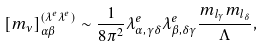<formula> <loc_0><loc_0><loc_500><loc_500>[ m _ { \nu } ] ^ { ( \lambda ^ { e } \lambda ^ { e } ) } _ { \alpha \beta } \sim \frac { 1 } { 8 \pi ^ { 2 } } \lambda ^ { e } _ { \alpha , \gamma \delta } \lambda ^ { e } _ { \beta , \delta \gamma } \frac { m _ { l _ { \gamma } } m _ { l _ { \delta } } } { \Lambda } ,</formula> 